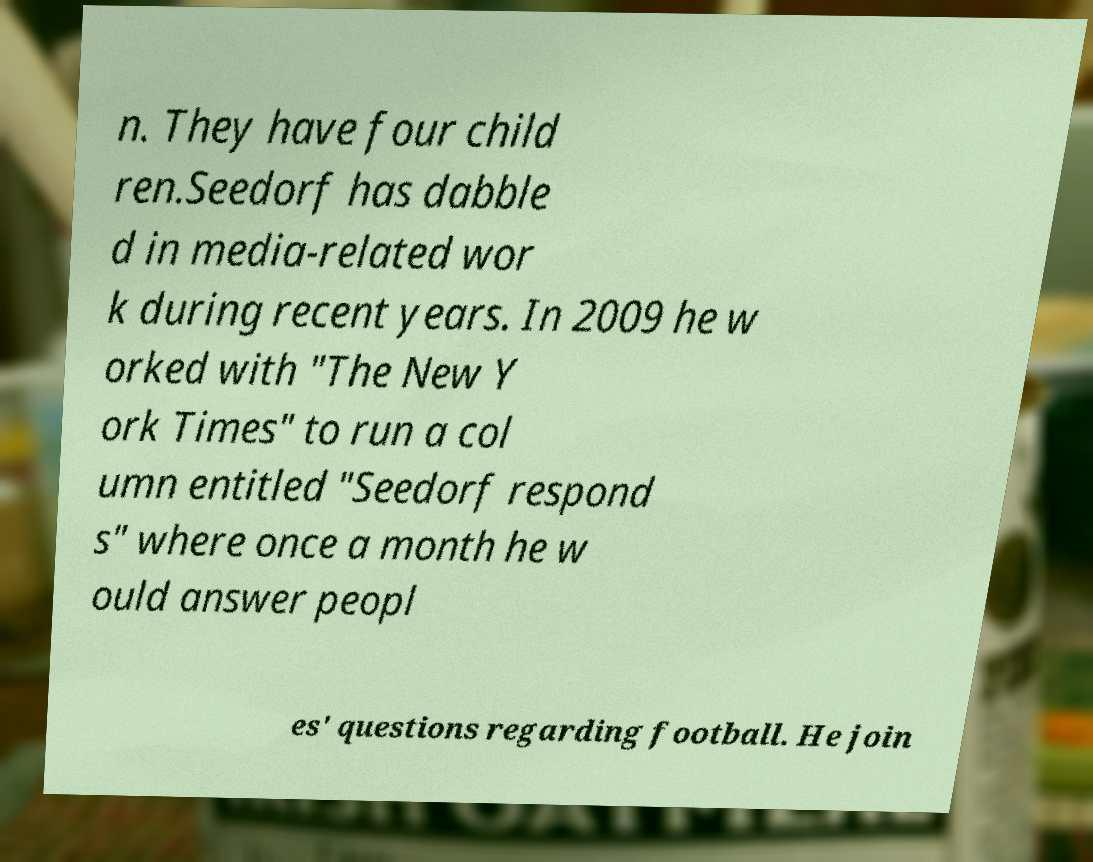Could you assist in decoding the text presented in this image and type it out clearly? n. They have four child ren.Seedorf has dabble d in media-related wor k during recent years. In 2009 he w orked with "The New Y ork Times" to run a col umn entitled "Seedorf respond s" where once a month he w ould answer peopl es' questions regarding football. He join 